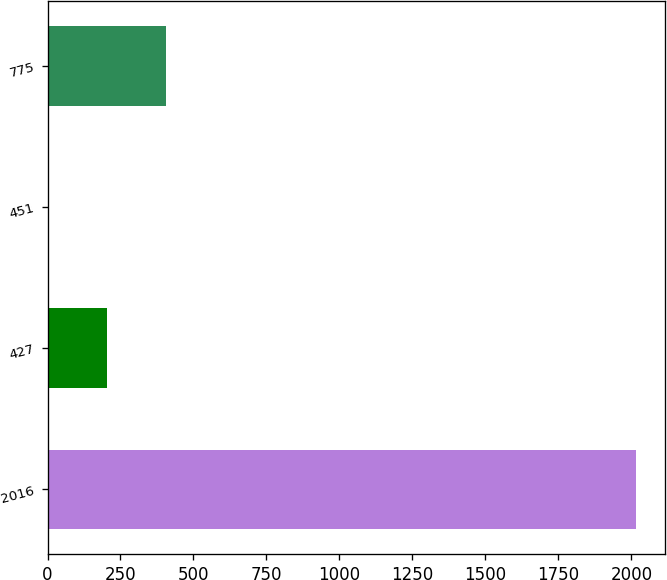Convert chart. <chart><loc_0><loc_0><loc_500><loc_500><bar_chart><fcel>2016<fcel>427<fcel>451<fcel>775<nl><fcel>2015<fcel>205.23<fcel>4.14<fcel>406.32<nl></chart> 